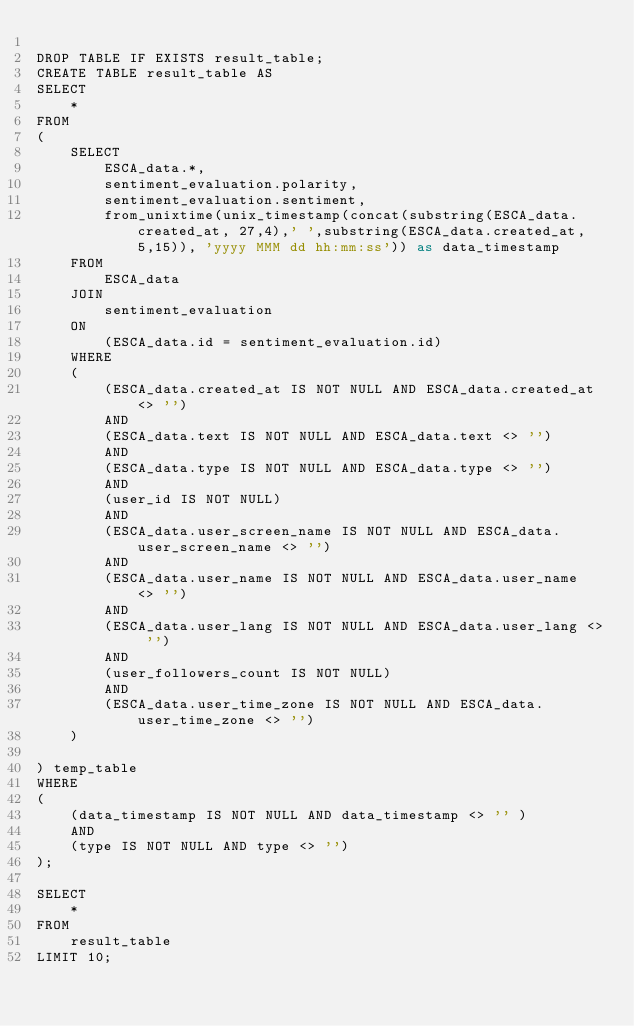Convert code to text. <code><loc_0><loc_0><loc_500><loc_500><_SQL_>
DROP TABLE IF EXISTS result_table;
CREATE TABLE result_table AS
SELECT
	*
FROM
(
	SELECT 
		ESCA_data.*,
		sentiment_evaluation.polarity,
		sentiment_evaluation.sentiment,
		from_unixtime(unix_timestamp(concat(substring(ESCA_data.created_at, 27,4),' ',substring(ESCA_data.created_at, 5,15)), 'yyyy MMM dd hh:mm:ss')) as data_timestamp
	FROM 
		ESCA_data
	JOIN
		sentiment_evaluation
	ON
		(ESCA_data.id = sentiment_evaluation.id)
	WHERE
	(
		(ESCA_data.created_at IS NOT NULL AND ESCA_data.created_at <> '')
		AND
		(ESCA_data.text IS NOT NULL AND ESCA_data.text <> '')
		AND
		(ESCA_data.type IS NOT NULL AND ESCA_data.type <> '')
		AND
		(user_id IS NOT NULL)
		AND
		(ESCA_data.user_screen_name IS NOT NULL AND ESCA_data.user_screen_name <> '')
		AND
		(ESCA_data.user_name IS NOT NULL AND ESCA_data.user_name  <> '')
		AND
		(ESCA_data.user_lang IS NOT NULL AND ESCA_data.user_lang <> '')
		AND
		(user_followers_count IS NOT NULL)
		AND
		(ESCA_data.user_time_zone IS NOT NULL AND ESCA_data.user_time_zone <> '')
	)
		
) temp_table
WHERE
(
	(data_timestamp IS NOT NULL AND data_timestamp <> '' )
	AND
	(type IS NOT NULL AND type <> '')
);

SELECT 
	* 
FROM 
	result_table
LIMIT 10;
</code> 